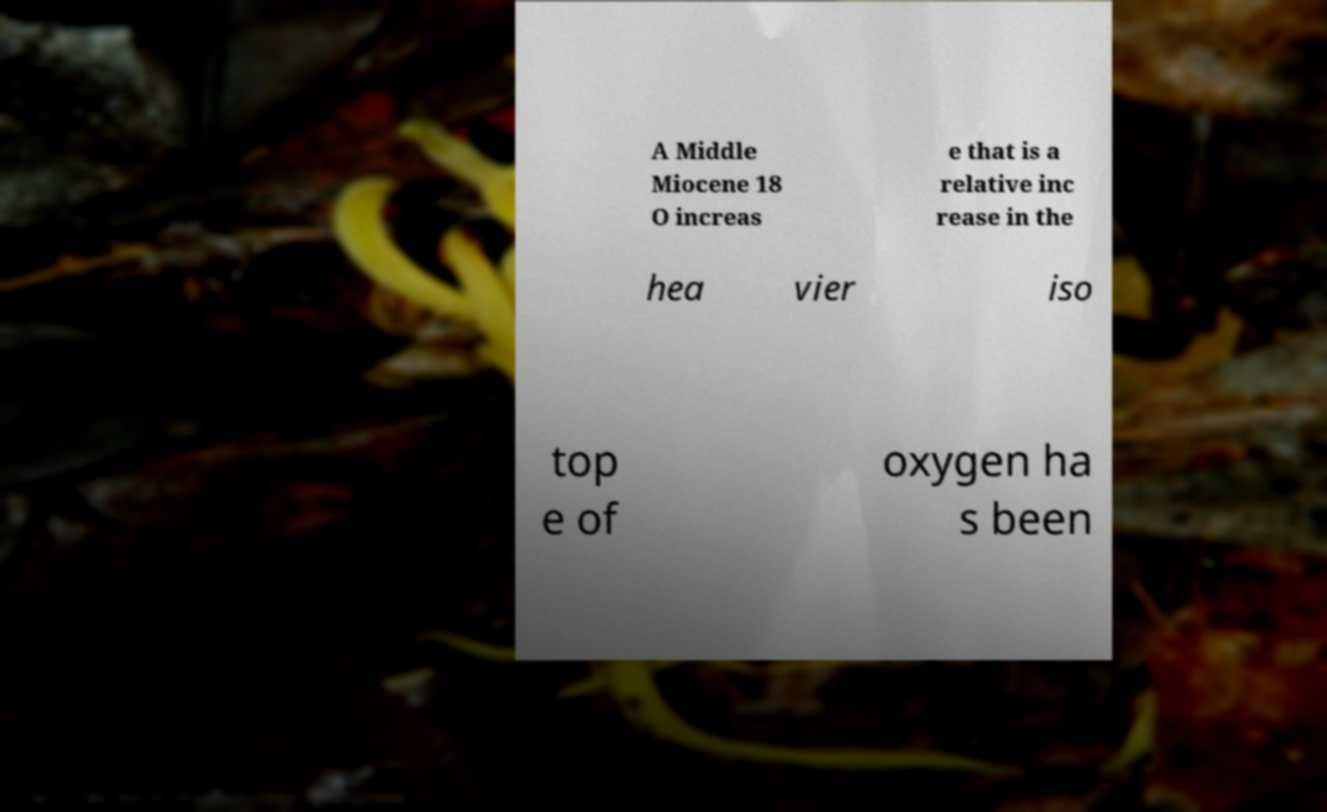For documentation purposes, I need the text within this image transcribed. Could you provide that? A Middle Miocene 18 O increas e that is a relative inc rease in the hea vier iso top e of oxygen ha s been 